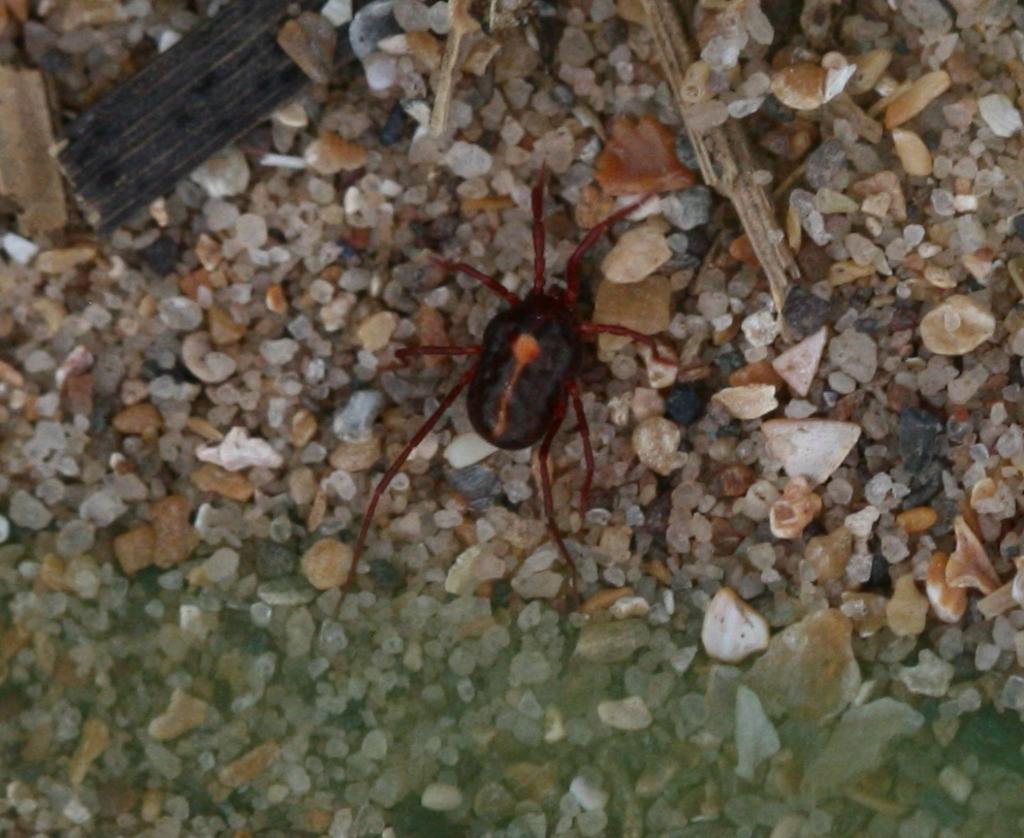Describe this image in one or two sentences. In this image I can see few small stones on the ground, few wooden sticks and an insect which is black, orange and red in color. 